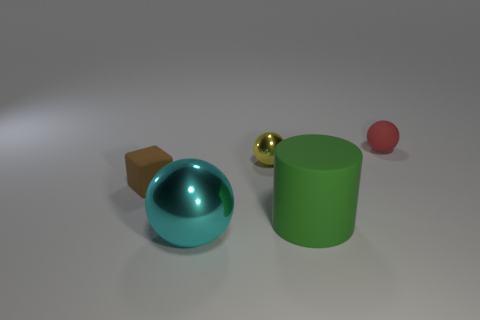How many other things are there of the same shape as the green rubber object?
Your answer should be very brief. 0. Are there fewer big cyan metal spheres than big yellow cylinders?
Ensure brevity in your answer.  No. There is a ball that is both behind the big green cylinder and left of the big green matte cylinder; what size is it?
Keep it short and to the point. Small. There is a sphere that is to the left of the metallic sphere that is behind the small thing on the left side of the cyan object; how big is it?
Provide a short and direct response. Large. What is the size of the green cylinder?
Offer a terse response. Large. Are there any yellow shiny things that are left of the matte thing in front of the small rubber object that is in front of the yellow object?
Provide a succinct answer. Yes. What number of big objects are either cyan things or brown matte cubes?
Ensure brevity in your answer.  1. There is a metal ball that is in front of the green rubber cylinder; is its size the same as the small cube?
Offer a terse response. No. The ball that is in front of the metallic sphere that is behind the tiny rubber thing in front of the red ball is what color?
Your answer should be compact. Cyan. The small block is what color?
Offer a terse response. Brown. 